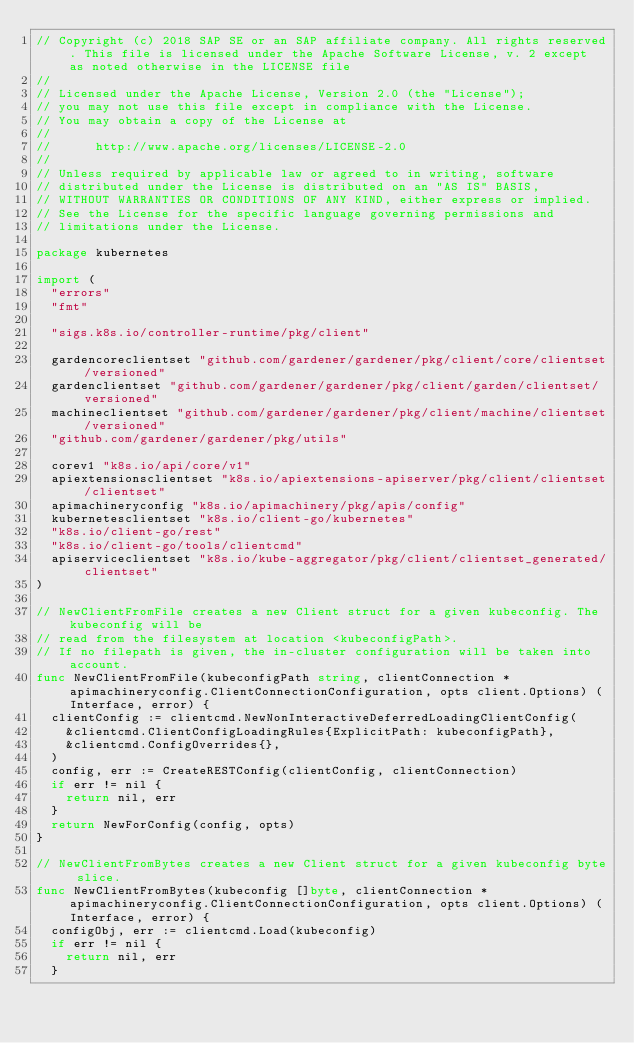Convert code to text. <code><loc_0><loc_0><loc_500><loc_500><_Go_>// Copyright (c) 2018 SAP SE or an SAP affiliate company. All rights reserved. This file is licensed under the Apache Software License, v. 2 except as noted otherwise in the LICENSE file
//
// Licensed under the Apache License, Version 2.0 (the "License");
// you may not use this file except in compliance with the License.
// You may obtain a copy of the License at
//
//      http://www.apache.org/licenses/LICENSE-2.0
//
// Unless required by applicable law or agreed to in writing, software
// distributed under the License is distributed on an "AS IS" BASIS,
// WITHOUT WARRANTIES OR CONDITIONS OF ANY KIND, either express or implied.
// See the License for the specific language governing permissions and
// limitations under the License.

package kubernetes

import (
	"errors"
	"fmt"

	"sigs.k8s.io/controller-runtime/pkg/client"

	gardencoreclientset "github.com/gardener/gardener/pkg/client/core/clientset/versioned"
	gardenclientset "github.com/gardener/gardener/pkg/client/garden/clientset/versioned"
	machineclientset "github.com/gardener/gardener/pkg/client/machine/clientset/versioned"
	"github.com/gardener/gardener/pkg/utils"

	corev1 "k8s.io/api/core/v1"
	apiextensionsclientset "k8s.io/apiextensions-apiserver/pkg/client/clientset/clientset"
	apimachineryconfig "k8s.io/apimachinery/pkg/apis/config"
	kubernetesclientset "k8s.io/client-go/kubernetes"
	"k8s.io/client-go/rest"
	"k8s.io/client-go/tools/clientcmd"
	apiserviceclientset "k8s.io/kube-aggregator/pkg/client/clientset_generated/clientset"
)

// NewClientFromFile creates a new Client struct for a given kubeconfig. The kubeconfig will be
// read from the filesystem at location <kubeconfigPath>.
// If no filepath is given, the in-cluster configuration will be taken into account.
func NewClientFromFile(kubeconfigPath string, clientConnection *apimachineryconfig.ClientConnectionConfiguration, opts client.Options) (Interface, error) {
	clientConfig := clientcmd.NewNonInteractiveDeferredLoadingClientConfig(
		&clientcmd.ClientConfigLoadingRules{ExplicitPath: kubeconfigPath},
		&clientcmd.ConfigOverrides{},
	)
	config, err := CreateRESTConfig(clientConfig, clientConnection)
	if err != nil {
		return nil, err
	}
	return NewForConfig(config, opts)
}

// NewClientFromBytes creates a new Client struct for a given kubeconfig byte slice.
func NewClientFromBytes(kubeconfig []byte, clientConnection *apimachineryconfig.ClientConnectionConfiguration, opts client.Options) (Interface, error) {
	configObj, err := clientcmd.Load(kubeconfig)
	if err != nil {
		return nil, err
	}</code> 